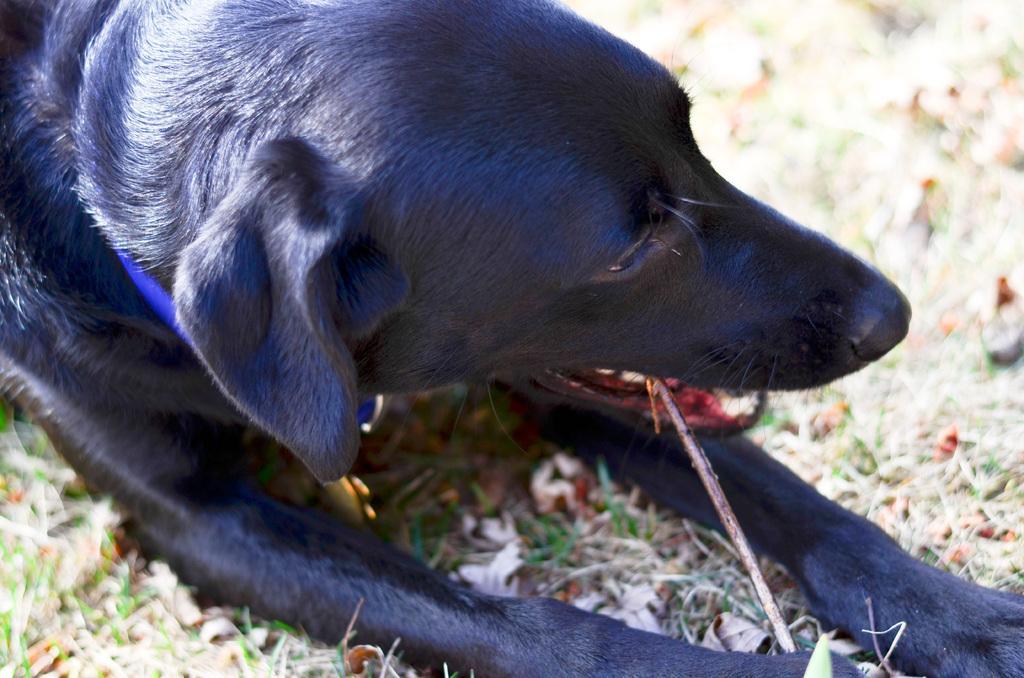Please provide a concise description of this image. In this image, I can see a black dog on the grass. 